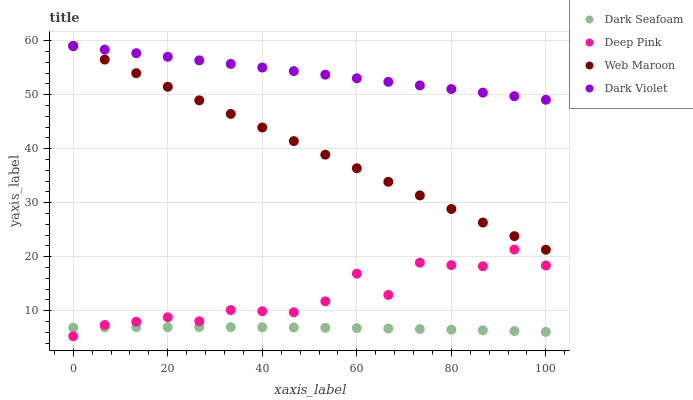Does Dark Seafoam have the minimum area under the curve?
Answer yes or no. Yes. Does Dark Violet have the maximum area under the curve?
Answer yes or no. Yes. Does Deep Pink have the minimum area under the curve?
Answer yes or no. No. Does Deep Pink have the maximum area under the curve?
Answer yes or no. No. Is Dark Violet the smoothest?
Answer yes or no. Yes. Is Deep Pink the roughest?
Answer yes or no. Yes. Is Web Maroon the smoothest?
Answer yes or no. No. Is Web Maroon the roughest?
Answer yes or no. No. Does Deep Pink have the lowest value?
Answer yes or no. Yes. Does Web Maroon have the lowest value?
Answer yes or no. No. Does Dark Violet have the highest value?
Answer yes or no. Yes. Does Deep Pink have the highest value?
Answer yes or no. No. Is Dark Seafoam less than Dark Violet?
Answer yes or no. Yes. Is Dark Violet greater than Deep Pink?
Answer yes or no. Yes. Does Dark Seafoam intersect Deep Pink?
Answer yes or no. Yes. Is Dark Seafoam less than Deep Pink?
Answer yes or no. No. Is Dark Seafoam greater than Deep Pink?
Answer yes or no. No. Does Dark Seafoam intersect Dark Violet?
Answer yes or no. No. 